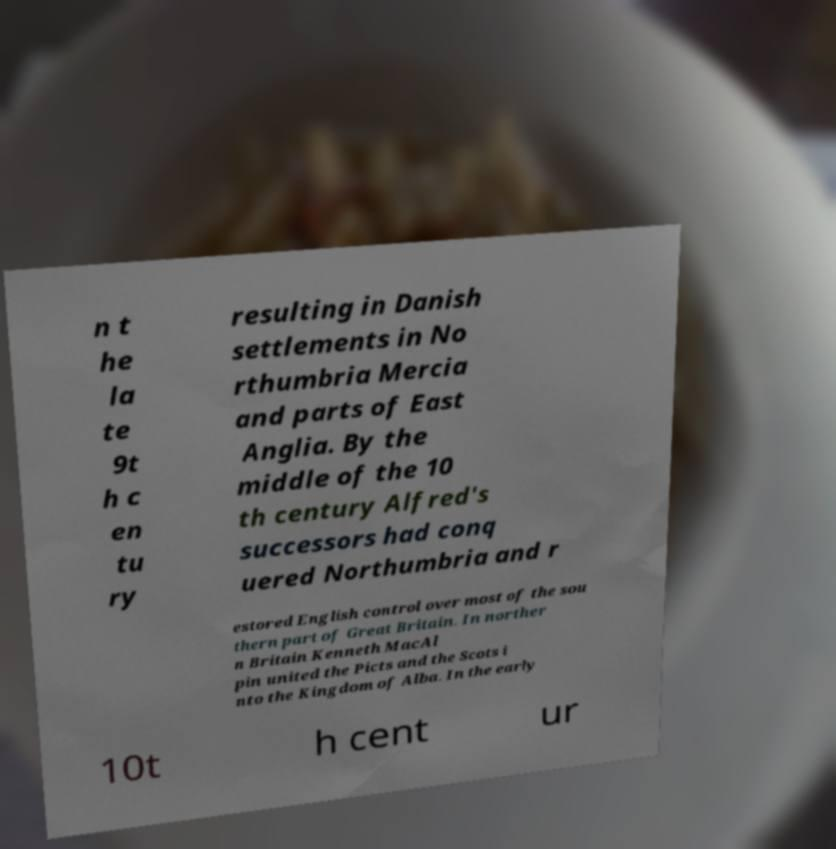Can you read and provide the text displayed in the image?This photo seems to have some interesting text. Can you extract and type it out for me? n t he la te 9t h c en tu ry resulting in Danish settlements in No rthumbria Mercia and parts of East Anglia. By the middle of the 10 th century Alfred's successors had conq uered Northumbria and r estored English control over most of the sou thern part of Great Britain. In norther n Britain Kenneth MacAl pin united the Picts and the Scots i nto the Kingdom of Alba. In the early 10t h cent ur 